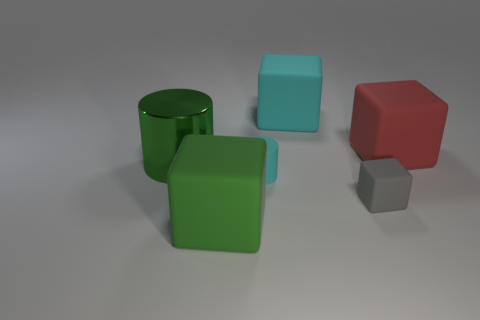How many things are either cubes that are behind the large green cylinder or gray rubber things?
Provide a short and direct response. 3. There is a matte block on the left side of the matte cylinder; how big is it?
Offer a terse response. Large. Are there fewer tiny rubber things than rubber blocks?
Ensure brevity in your answer.  Yes. Does the big thing on the right side of the tiny gray matte block have the same material as the cylinder behind the tiny cyan thing?
Give a very brief answer. No. What shape is the tiny object in front of the small object that is left of the matte thing that is behind the big red matte thing?
Provide a short and direct response. Cube. What number of large red blocks are the same material as the big green block?
Your answer should be very brief. 1. What number of small rubber cylinders are behind the large object that is to the right of the tiny gray matte thing?
Your answer should be compact. 0. There is a cube that is left of the rubber cylinder; is its color the same as the cylinder that is on the left side of the tiny cyan thing?
Offer a terse response. Yes. The matte object that is right of the small matte cylinder and to the left of the gray rubber object has what shape?
Your answer should be compact. Cube. Are there any small cyan objects that have the same shape as the big shiny thing?
Your answer should be compact. Yes. 